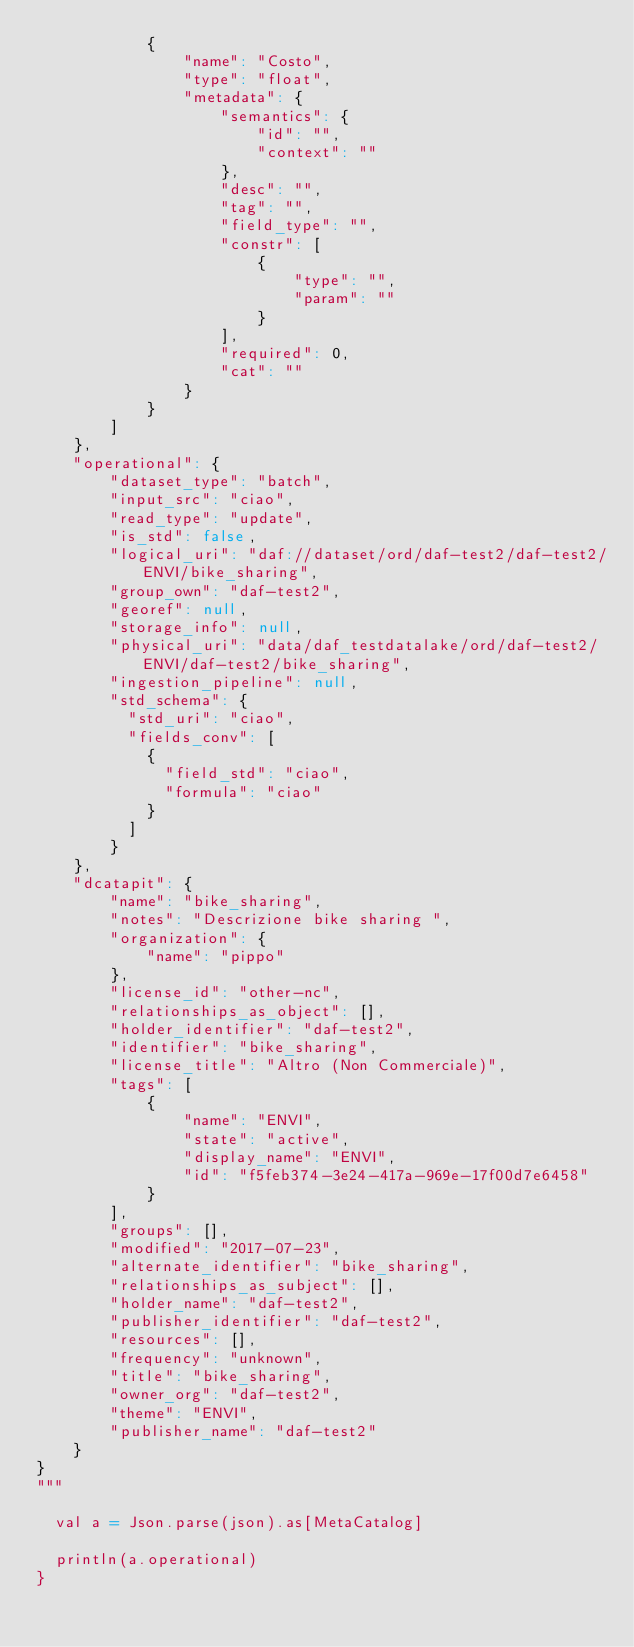<code> <loc_0><loc_0><loc_500><loc_500><_Scala_>            {
                "name": "Costo",
                "type": "float",
                "metadata": {
                    "semantics": {
                        "id": "",
                        "context": ""
                    },
                    "desc": "",
                    "tag": "",
                    "field_type": "",
                    "constr": [
                        {
                            "type": "",
                            "param": ""
                        }
                    ],
                    "required": 0,
                    "cat": ""
                }
            }
        ]
    },
    "operational": {
        "dataset_type": "batch",
        "input_src": "ciao",
        "read_type": "update",
        "is_std": false,
        "logical_uri": "daf://dataset/ord/daf-test2/daf-test2/ENVI/bike_sharing",
        "group_own": "daf-test2",
        "georef": null,
        "storage_info": null,
        "physical_uri": "data/daf_testdatalake/ord/daf-test2/ENVI/daf-test2/bike_sharing",
        "ingestion_pipeline": null,
        "std_schema": {
          "std_uri": "ciao",
          "fields_conv": [
            {
              "field_std": "ciao",
              "formula": "ciao"
            }
          ]
        }
    },
    "dcatapit": {
        "name": "bike_sharing",
        "notes": "Descrizione bike sharing ",
        "organization": {
            "name": "pippo"
        },
        "license_id": "other-nc",
        "relationships_as_object": [],
        "holder_identifier": "daf-test2",
        "identifier": "bike_sharing",
        "license_title": "Altro (Non Commerciale)",
        "tags": [
            {
                "name": "ENVI",
                "state": "active",
                "display_name": "ENVI",
                "id": "f5feb374-3e24-417a-969e-17f00d7e6458"
            }
        ],
        "groups": [],
        "modified": "2017-07-23",
        "alternate_identifier": "bike_sharing",
        "relationships_as_subject": [],
        "holder_name": "daf-test2",
        "publisher_identifier": "daf-test2",
        "resources": [],
        "frequency": "unknown",
        "title": "bike_sharing",
        "owner_org": "daf-test2",
        "theme": "ENVI",
        "publisher_name": "daf-test2"
    }
}
"""

  val a = Json.parse(json).as[MetaCatalog]

  println(a.operational)
}
</code> 